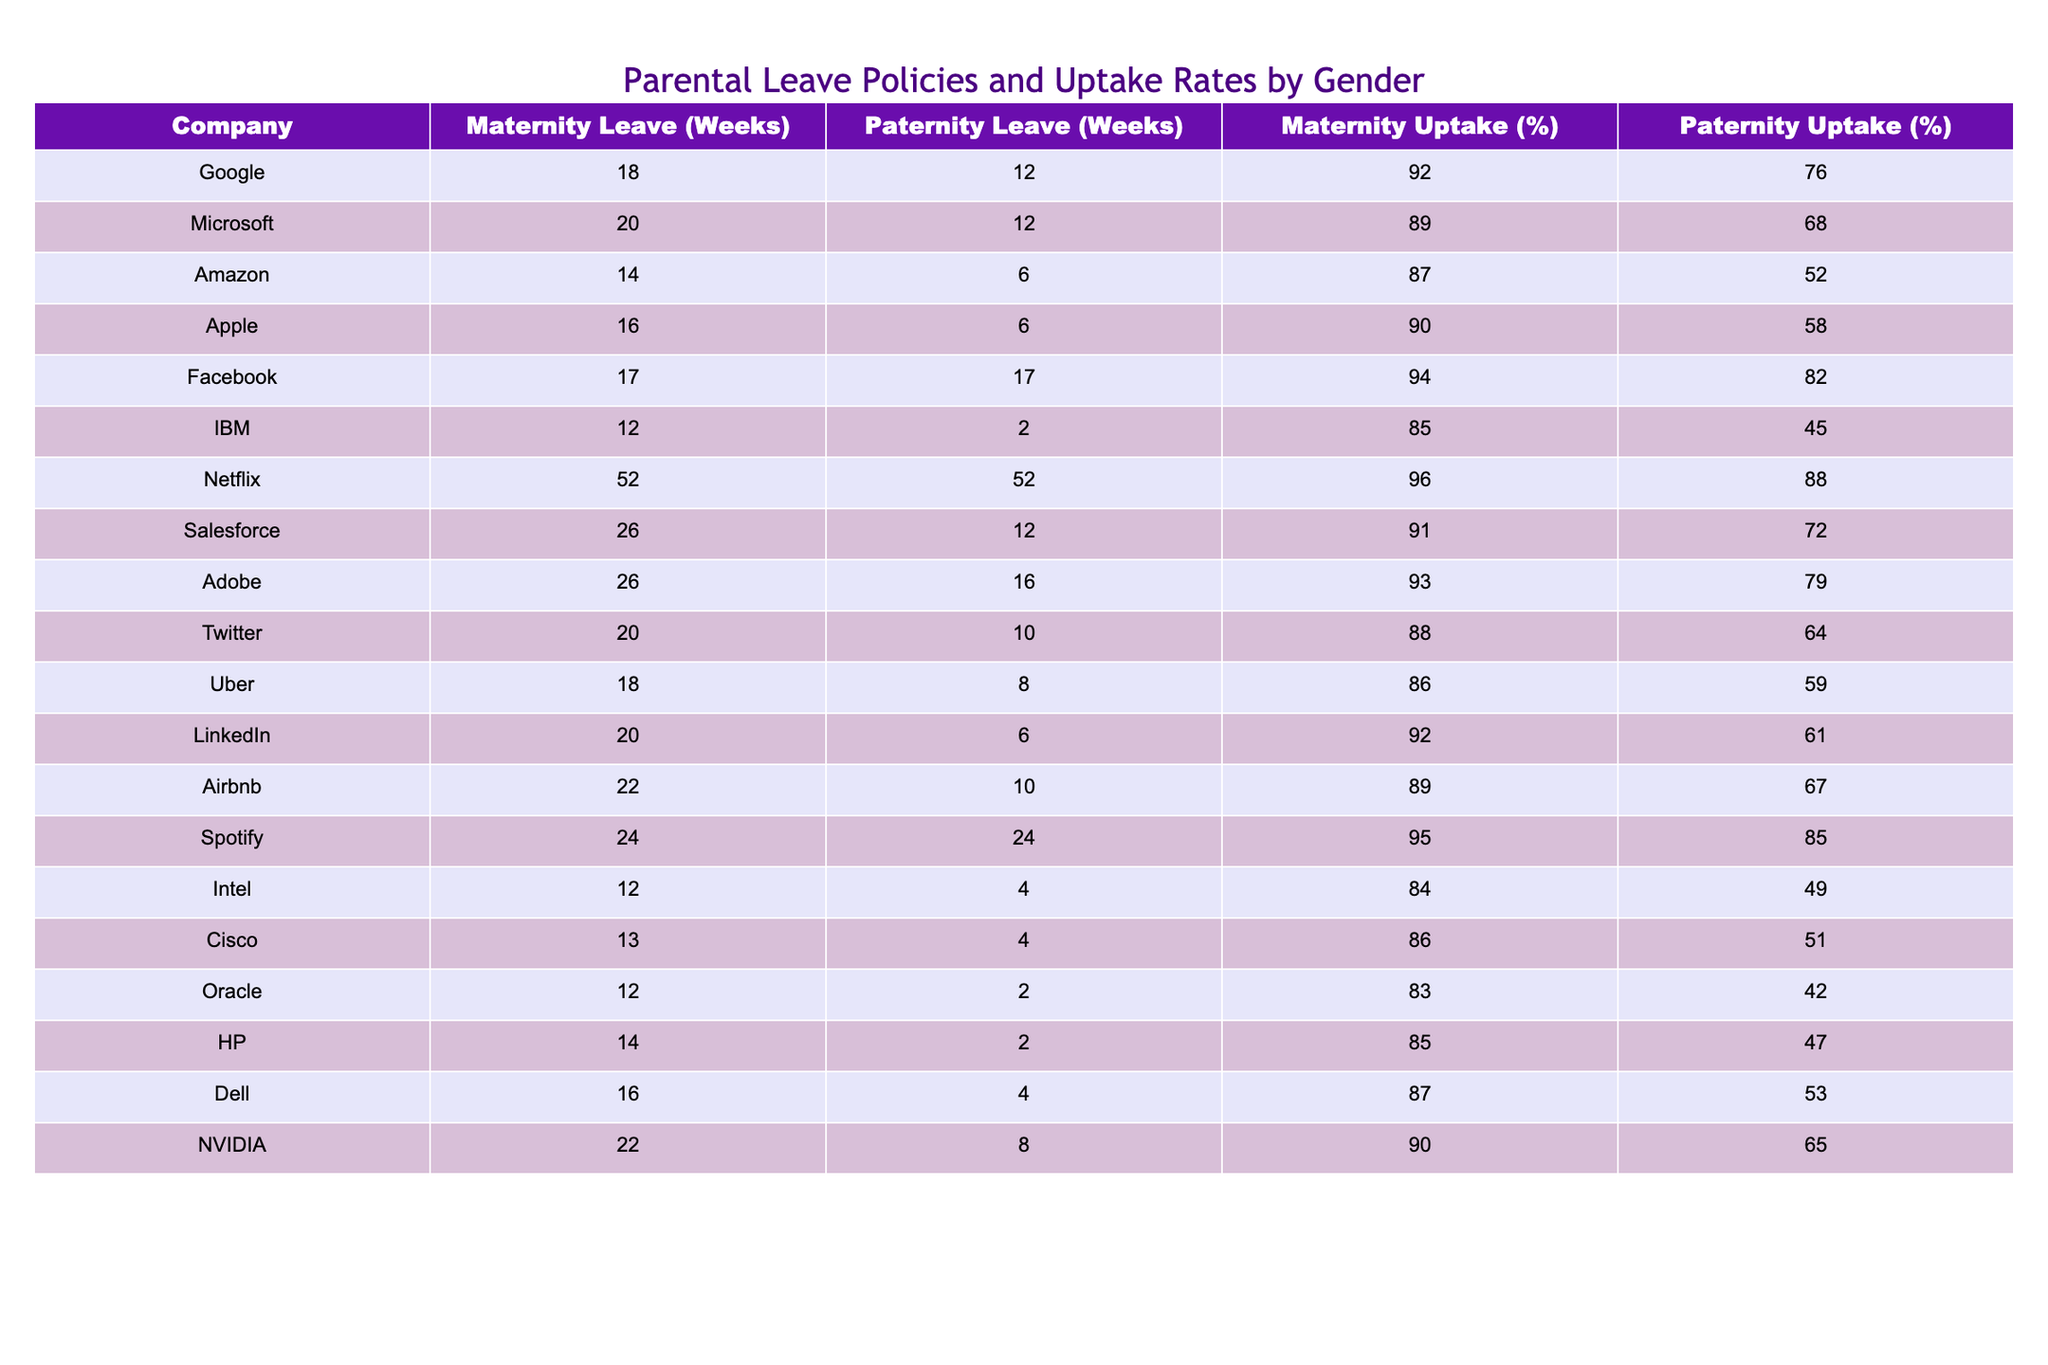What is the maternity leave offered by Microsoft? The table lists the maternity leave for each company, and for Microsoft, it shows 20 weeks of maternity leave.
Answer: 20 weeks Which company has the highest maternity uptake percentage? By reviewing the maternity uptake percentages in the table, Netflix has the highest percentage at 96%.
Answer: 96% What is the average paternity leave offered across all the companies? To find the average paternity leave, sum all the paternity leave values (12 + 12 + 6 + 6 + 17 + 2 + 52 + 12 + 16 + 10 + 8 + 6 + 10 + 24 + 4 + 4 + 2 + 2 + 4 + 8) = 264 weeks. There are 20 companies, so the average is 264 / 20 = 13.2 weeks.
Answer: 13.2 weeks Is the paternity uptake percentage for IBM higher than that for Oracle? IBM's paternity uptake is 45% and Oracle's is 42%. Since 45% is greater than 42%, the statement is true.
Answer: Yes What is the difference in maternity leave between Netflix and Amazon? Netflix offers 52 weeks of maternity leave and Amazon offers 14 weeks. The difference is calculated as 52 - 14 = 38 weeks.
Answer: 38 weeks Which company has a maternity leave duration less than 15 weeks? Reviewing the table, Amazon (14 weeks), IBM (12 weeks), Oracle (12 weeks), HP (14 weeks), and Cisco (13 weeks) all have less than 15 weeks of maternity leave.
Answer: Amazon, IBM, Oracle, HP, Cisco What is the relationship between maternity leave and maternity uptake for Facebook? Facebook has 17 weeks of maternity leave and an uptake of 94%. The relationship indicates that a higher maternity leave may correlate with a higher uptake.
Answer: Higher maternity leave correlates with higher uptake Which two companies have the most similar paternity leave durations, and what is that duration? By comparing the paternity leave, both Cisco and Oracle have a leave duration of 2 weeks, making them similar.
Answer: 2 weeks What is the ratio of maternity leave to paternity leave for Google? Google offers 18 weeks of maternity leave and 12 weeks of paternity leave. The ratio is therefore 18:12, which simplifies to 3:2.
Answer: 3:2 Are there any companies with paternity uptake percentages below 50%? Reviewing the paternity uptake percentages in the table, both IBM (45%), Oracle (42%), and Amazon (52%) have uptake percentages below 50%.
Answer: Yes What percentage of companies provide at least 20 weeks of maternity leave? Counting the companies with maternity leave of 20 weeks or more (Microsoft, Salesforce, Adobe, Netflix), there are 4 such companies out of 20. Therefore, the percentage is (4/20) * 100 = 20%.
Answer: 20% 